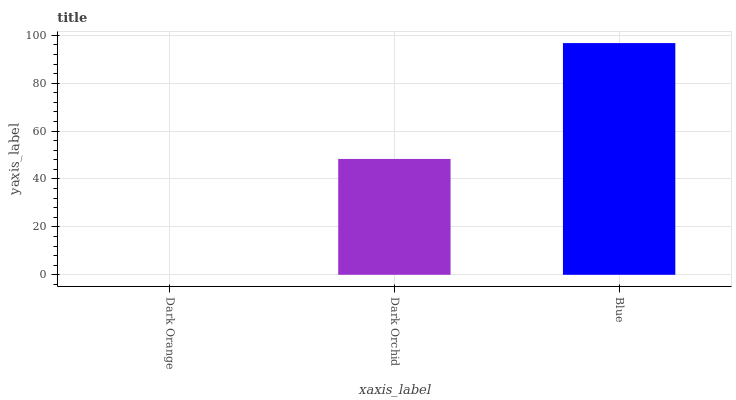Is Dark Orchid the minimum?
Answer yes or no. No. Is Dark Orchid the maximum?
Answer yes or no. No. Is Dark Orchid greater than Dark Orange?
Answer yes or no. Yes. Is Dark Orange less than Dark Orchid?
Answer yes or no. Yes. Is Dark Orange greater than Dark Orchid?
Answer yes or no. No. Is Dark Orchid less than Dark Orange?
Answer yes or no. No. Is Dark Orchid the high median?
Answer yes or no. Yes. Is Dark Orchid the low median?
Answer yes or no. Yes. Is Dark Orange the high median?
Answer yes or no. No. Is Blue the low median?
Answer yes or no. No. 